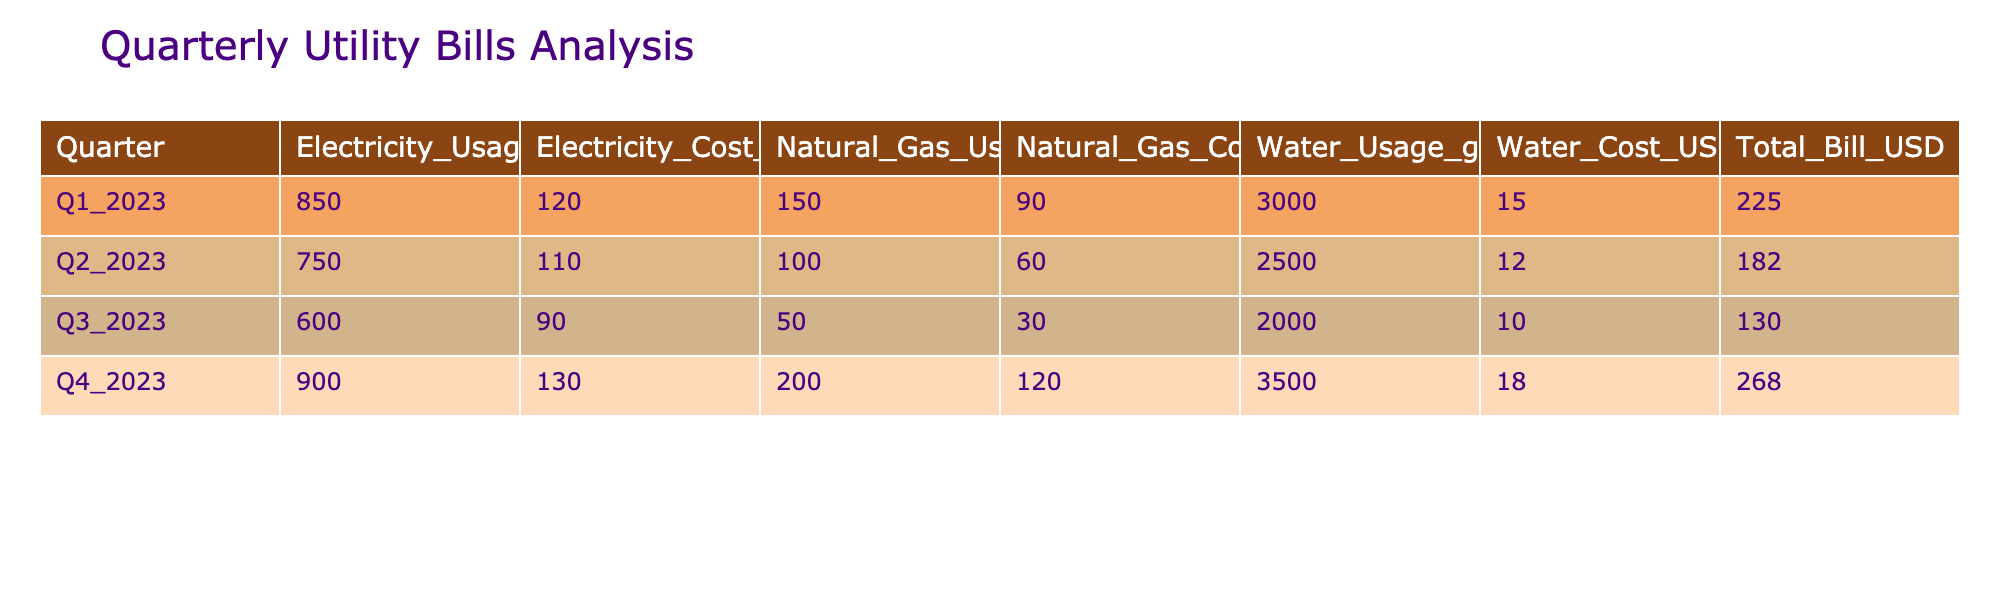What was the total electricity cost in Q4 2023? Looking at the table, the electricity cost in Q4 2023 is listed as 130 USD.
Answer: 130 USD What is the average natural gas usage over the four quarters? To find the average natural gas usage, we sum the natural gas usage for all quarters: 150 + 100 + 50 + 200 = 500 therms. We then divide by 4 (the number of quarters): 500 / 4 = 125 therms.
Answer: 125 therms Did the total bill in Q3 2023 exceed that of Q1 2023? The total bill for Q3 2023 is 130 USD, while the total bill for Q1 2023 is 225 USD. Since 130 is less than 225, the answer is no.
Answer: No Which quarter had the highest total bill? Examining the total bill column, Q4 2023 has the highest total bill at 268 USD, compared to other quarters' total bills.
Answer: Q4 2023 What is the difference in water cost between Q2 2023 and Q4 2023? The water cost for Q2 2023 is 12 USD and for Q4 2023 is 18 USD. The difference is calculated as 18 - 12 = 6 USD.
Answer: 6 USD Is the electricity cost in Q1 2023 greater than the average electricity cost for the year? First, we find the average electricity cost: (120 + 110 + 90 + 130) / 4 = 112.5 USD. Then, we compare Q1's cost (120 USD) to the average (112.5 USD), and since 120 is greater, the answer is yes.
Answer: Yes Which quarter had the least water usage, and how much was it? Looking at the water usage column, Q3 2023 had the least water usage at 2000 gallons, which is less than the other quarters.
Answer: Q3 2023, 2000 gallons What was the total usage of electricity, natural gas, and water combined in Q1 2023? The total usage in Q1 2023 is the sum of electricity usage (850 kWh), natural gas usage (150 therms), and water usage (3000 gallons). The total is 850 + 150 + 3000 = 4000.
Answer: 4000 units (kWh + therms + gallons) Did the natural gas cost in Q1 2023 double the natural gas cost in Q3 2023? The natural gas cost in Q1 is 90 USD, and in Q3 it's 30 USD. Doubling the cost in Q3 would be 30 * 2 = 60 USD. Since 90 is greater than 60, the answer is yes.
Answer: Yes What was the highest water usage in gallons across the quarters? Scanning the water usage data, Q4 2023 has the highest usage at 3500 gallons compared to other quarters.
Answer: 3500 gallons 